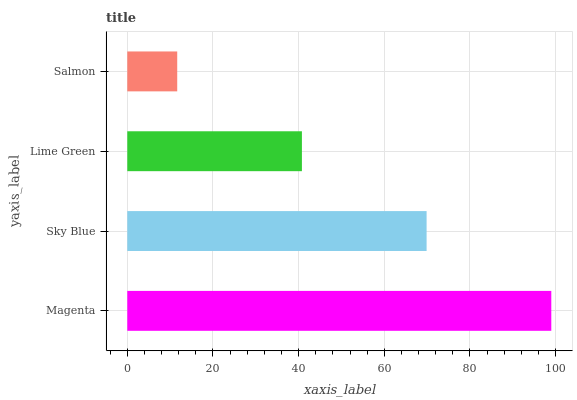Is Salmon the minimum?
Answer yes or no. Yes. Is Magenta the maximum?
Answer yes or no. Yes. Is Sky Blue the minimum?
Answer yes or no. No. Is Sky Blue the maximum?
Answer yes or no. No. Is Magenta greater than Sky Blue?
Answer yes or no. Yes. Is Sky Blue less than Magenta?
Answer yes or no. Yes. Is Sky Blue greater than Magenta?
Answer yes or no. No. Is Magenta less than Sky Blue?
Answer yes or no. No. Is Sky Blue the high median?
Answer yes or no. Yes. Is Lime Green the low median?
Answer yes or no. Yes. Is Lime Green the high median?
Answer yes or no. No. Is Magenta the low median?
Answer yes or no. No. 